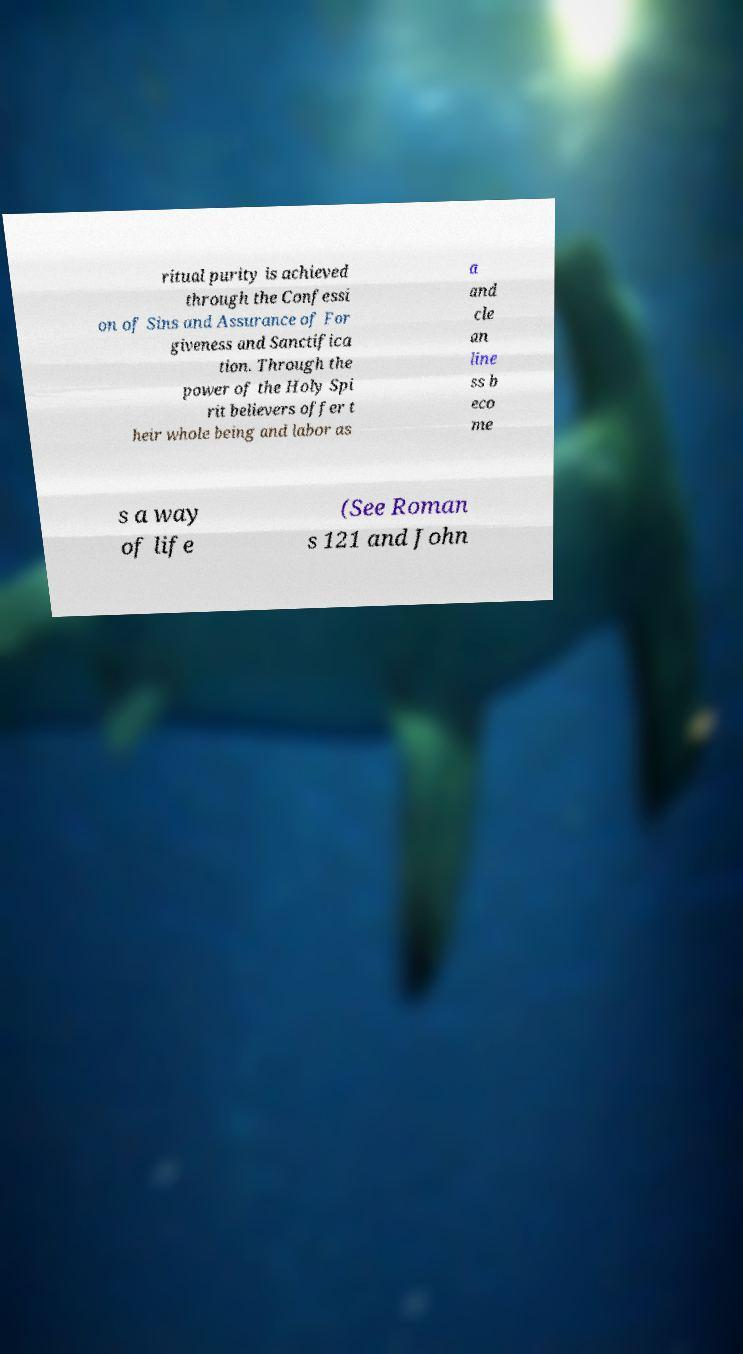Please read and relay the text visible in this image. What does it say? ritual purity is achieved through the Confessi on of Sins and Assurance of For giveness and Sanctifica tion. Through the power of the Holy Spi rit believers offer t heir whole being and labor as a and cle an line ss b eco me s a way of life (See Roman s 121 and John 